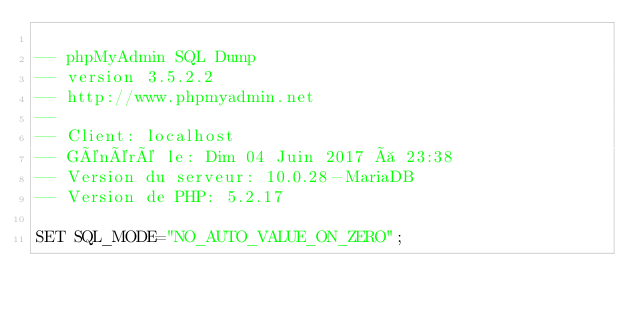<code> <loc_0><loc_0><loc_500><loc_500><_SQL_>
-- phpMyAdmin SQL Dump
-- version 3.5.2.2
-- http://www.phpmyadmin.net
--
-- Client: localhost
-- Généré le: Dim 04 Juin 2017 à 23:38
-- Version du serveur: 10.0.28-MariaDB
-- Version de PHP: 5.2.17

SET SQL_MODE="NO_AUTO_VALUE_ON_ZERO";</code> 